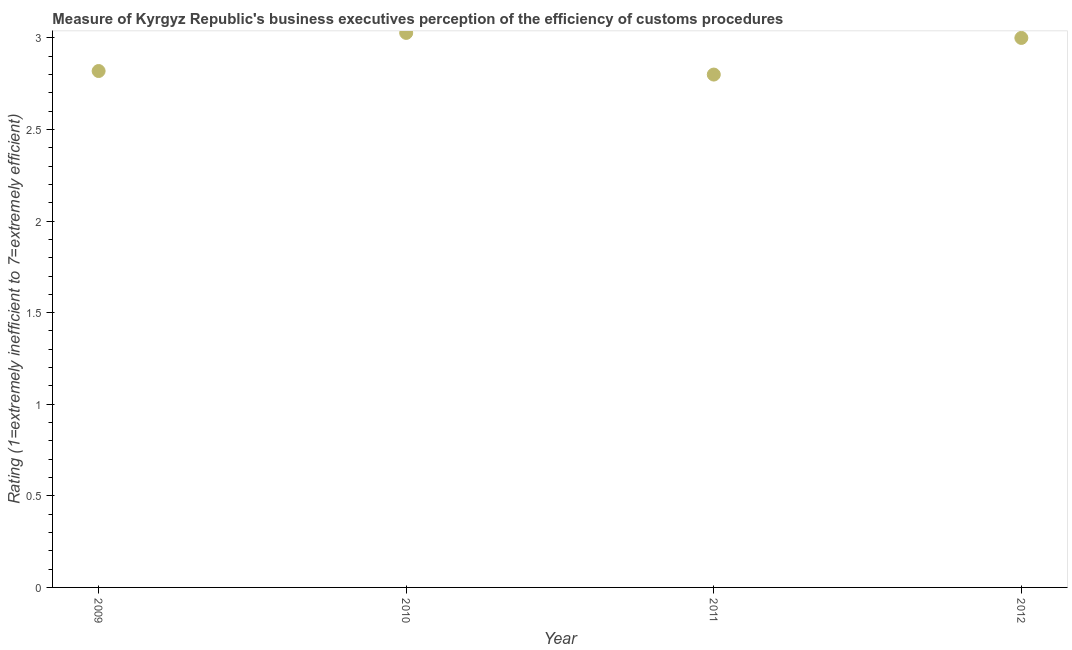What is the rating measuring burden of customs procedure in 2010?
Your answer should be compact. 3.03. Across all years, what is the maximum rating measuring burden of customs procedure?
Provide a succinct answer. 3.03. In which year was the rating measuring burden of customs procedure maximum?
Your answer should be compact. 2010. In which year was the rating measuring burden of customs procedure minimum?
Offer a terse response. 2011. What is the sum of the rating measuring burden of customs procedure?
Offer a terse response. 11.65. What is the difference between the rating measuring burden of customs procedure in 2009 and 2012?
Provide a succinct answer. -0.18. What is the average rating measuring burden of customs procedure per year?
Provide a succinct answer. 2.91. What is the median rating measuring burden of customs procedure?
Give a very brief answer. 2.91. In how many years, is the rating measuring burden of customs procedure greater than 1 ?
Make the answer very short. 4. Do a majority of the years between 2011 and 2010 (inclusive) have rating measuring burden of customs procedure greater than 1.4 ?
Offer a very short reply. No. What is the ratio of the rating measuring burden of customs procedure in 2011 to that in 2012?
Your response must be concise. 0.93. Is the difference between the rating measuring burden of customs procedure in 2010 and 2012 greater than the difference between any two years?
Offer a very short reply. No. What is the difference between the highest and the second highest rating measuring burden of customs procedure?
Provide a short and direct response. 0.03. What is the difference between the highest and the lowest rating measuring burden of customs procedure?
Keep it short and to the point. 0.23. Does the rating measuring burden of customs procedure monotonically increase over the years?
Offer a terse response. No. How many dotlines are there?
Provide a succinct answer. 1. How many years are there in the graph?
Provide a short and direct response. 4. Does the graph contain grids?
Make the answer very short. No. What is the title of the graph?
Your response must be concise. Measure of Kyrgyz Republic's business executives perception of the efficiency of customs procedures. What is the label or title of the Y-axis?
Give a very brief answer. Rating (1=extremely inefficient to 7=extremely efficient). What is the Rating (1=extremely inefficient to 7=extremely efficient) in 2009?
Give a very brief answer. 2.82. What is the Rating (1=extremely inefficient to 7=extremely efficient) in 2010?
Make the answer very short. 3.03. What is the Rating (1=extremely inefficient to 7=extremely efficient) in 2011?
Your answer should be very brief. 2.8. What is the Rating (1=extremely inefficient to 7=extremely efficient) in 2012?
Offer a terse response. 3. What is the difference between the Rating (1=extremely inefficient to 7=extremely efficient) in 2009 and 2010?
Provide a succinct answer. -0.21. What is the difference between the Rating (1=extremely inefficient to 7=extremely efficient) in 2009 and 2011?
Give a very brief answer. 0.02. What is the difference between the Rating (1=extremely inefficient to 7=extremely efficient) in 2009 and 2012?
Give a very brief answer. -0.18. What is the difference between the Rating (1=extremely inefficient to 7=extremely efficient) in 2010 and 2011?
Your response must be concise. 0.23. What is the difference between the Rating (1=extremely inefficient to 7=extremely efficient) in 2010 and 2012?
Ensure brevity in your answer.  0.03. What is the ratio of the Rating (1=extremely inefficient to 7=extremely efficient) in 2009 to that in 2010?
Provide a short and direct response. 0.93. What is the ratio of the Rating (1=extremely inefficient to 7=extremely efficient) in 2009 to that in 2011?
Your answer should be very brief. 1.01. What is the ratio of the Rating (1=extremely inefficient to 7=extremely efficient) in 2009 to that in 2012?
Provide a succinct answer. 0.94. What is the ratio of the Rating (1=extremely inefficient to 7=extremely efficient) in 2010 to that in 2011?
Offer a very short reply. 1.08. What is the ratio of the Rating (1=extremely inefficient to 7=extremely efficient) in 2011 to that in 2012?
Your answer should be compact. 0.93. 